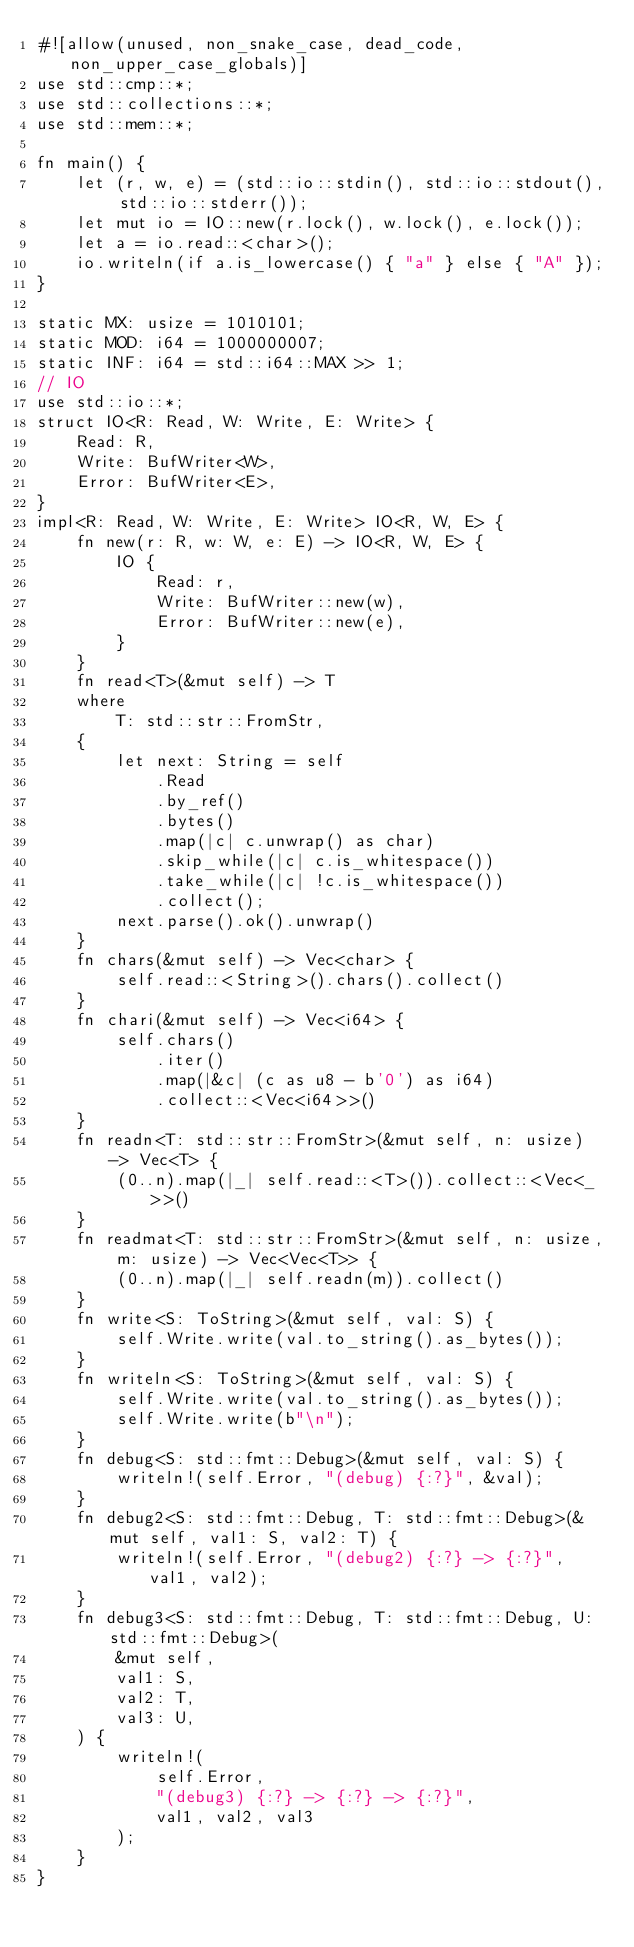<code> <loc_0><loc_0><loc_500><loc_500><_Rust_>#![allow(unused, non_snake_case, dead_code, non_upper_case_globals)]
use std::cmp::*;
use std::collections::*;
use std::mem::*;

fn main() {
    let (r, w, e) = (std::io::stdin(), std::io::stdout(), std::io::stderr());
    let mut io = IO::new(r.lock(), w.lock(), e.lock());
    let a = io.read::<char>();
    io.writeln(if a.is_lowercase() { "a" } else { "A" });
}

static MX: usize = 1010101;
static MOD: i64 = 1000000007;
static INF: i64 = std::i64::MAX >> 1;
// IO
use std::io::*;
struct IO<R: Read, W: Write, E: Write> {
    Read: R,
    Write: BufWriter<W>,
    Error: BufWriter<E>,
}
impl<R: Read, W: Write, E: Write> IO<R, W, E> {
    fn new(r: R, w: W, e: E) -> IO<R, W, E> {
        IO {
            Read: r,
            Write: BufWriter::new(w),
            Error: BufWriter::new(e),
        }
    }
    fn read<T>(&mut self) -> T
    where
        T: std::str::FromStr,
    {
        let next: String = self
            .Read
            .by_ref()
            .bytes()
            .map(|c| c.unwrap() as char)
            .skip_while(|c| c.is_whitespace())
            .take_while(|c| !c.is_whitespace())
            .collect();
        next.parse().ok().unwrap()
    }
    fn chars(&mut self) -> Vec<char> {
        self.read::<String>().chars().collect()
    }
    fn chari(&mut self) -> Vec<i64> {
        self.chars()
            .iter()
            .map(|&c| (c as u8 - b'0') as i64)
            .collect::<Vec<i64>>()
    }
    fn readn<T: std::str::FromStr>(&mut self, n: usize) -> Vec<T> {
        (0..n).map(|_| self.read::<T>()).collect::<Vec<_>>()
    }
    fn readmat<T: std::str::FromStr>(&mut self, n: usize, m: usize) -> Vec<Vec<T>> {
        (0..n).map(|_| self.readn(m)).collect()
    }
    fn write<S: ToString>(&mut self, val: S) {
        self.Write.write(val.to_string().as_bytes());
    }
    fn writeln<S: ToString>(&mut self, val: S) {
        self.Write.write(val.to_string().as_bytes());
        self.Write.write(b"\n");
    }
    fn debug<S: std::fmt::Debug>(&mut self, val: S) {
        writeln!(self.Error, "(debug) {:?}", &val);
    }
    fn debug2<S: std::fmt::Debug, T: std::fmt::Debug>(&mut self, val1: S, val2: T) {
        writeln!(self.Error, "(debug2) {:?} -> {:?}", val1, val2);
    }
    fn debug3<S: std::fmt::Debug, T: std::fmt::Debug, U: std::fmt::Debug>(
        &mut self,
        val1: S,
        val2: T,
        val3: U,
    ) {
        writeln!(
            self.Error,
            "(debug3) {:?} -> {:?} -> {:?}",
            val1, val2, val3
        );
    }
}
</code> 